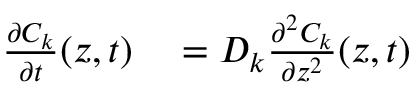<formula> <loc_0><loc_0><loc_500><loc_500>\begin{array} { r l } { \frac { \partial C _ { k } } { \partial t } ( z , t ) } & = D _ { k } \frac { \partial ^ { 2 } C _ { k } } { \partial z ^ { 2 } } ( z , t ) } \end{array}</formula> 